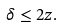<formula> <loc_0><loc_0><loc_500><loc_500>\delta \leq 2 z .</formula> 